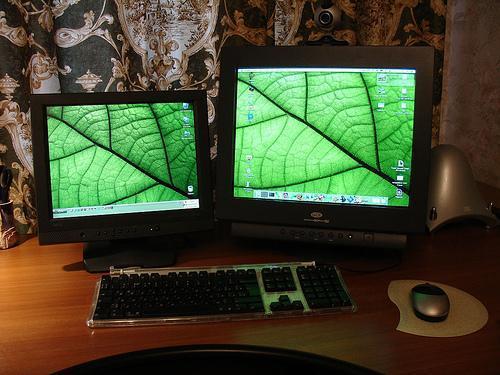How many computer monitors are there?
Give a very brief answer. 2. How many tvs can you see?
Give a very brief answer. 2. 